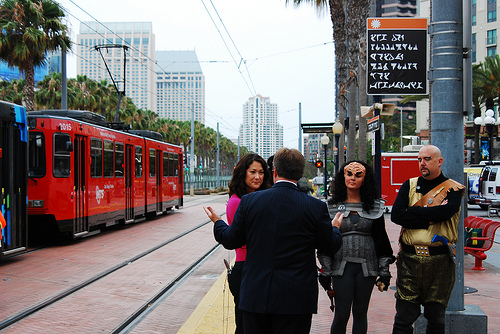<image>
Is there a train on the man? No. The train is not positioned on the man. They may be near each other, but the train is not supported by or resting on top of the man. 